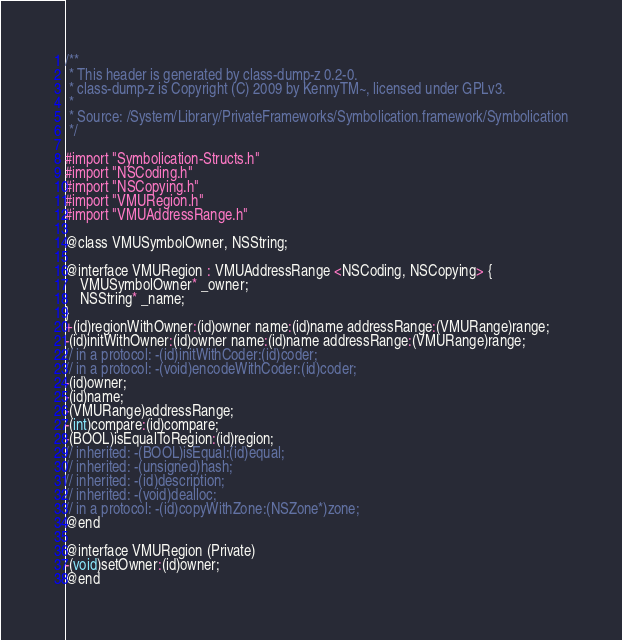Convert code to text. <code><loc_0><loc_0><loc_500><loc_500><_C_>/**
 * This header is generated by class-dump-z 0.2-0.
 * class-dump-z is Copyright (C) 2009 by KennyTM~, licensed under GPLv3.
 *
 * Source: /System/Library/PrivateFrameworks/Symbolication.framework/Symbolication
 */

#import "Symbolication-Structs.h"
#import "NSCoding.h"
#import "NSCopying.h"
#import "VMURegion.h"
#import "VMUAddressRange.h"

@class VMUSymbolOwner, NSString;

@interface VMURegion : VMUAddressRange <NSCoding, NSCopying> {
	VMUSymbolOwner* _owner;
	NSString* _name;
}
+(id)regionWithOwner:(id)owner name:(id)name addressRange:(VMURange)range;
-(id)initWithOwner:(id)owner name:(id)name addressRange:(VMURange)range;
// in a protocol: -(id)initWithCoder:(id)coder;
// in a protocol: -(void)encodeWithCoder:(id)coder;
-(id)owner;
-(id)name;
-(VMURange)addressRange;
-(int)compare:(id)compare;
-(BOOL)isEqualToRegion:(id)region;
// inherited: -(BOOL)isEqual:(id)equal;
// inherited: -(unsigned)hash;
// inherited: -(id)description;
// inherited: -(void)dealloc;
// in a protocol: -(id)copyWithZone:(NSZone*)zone;
@end

@interface VMURegion (Private)
-(void)setOwner:(id)owner;
@end

</code> 